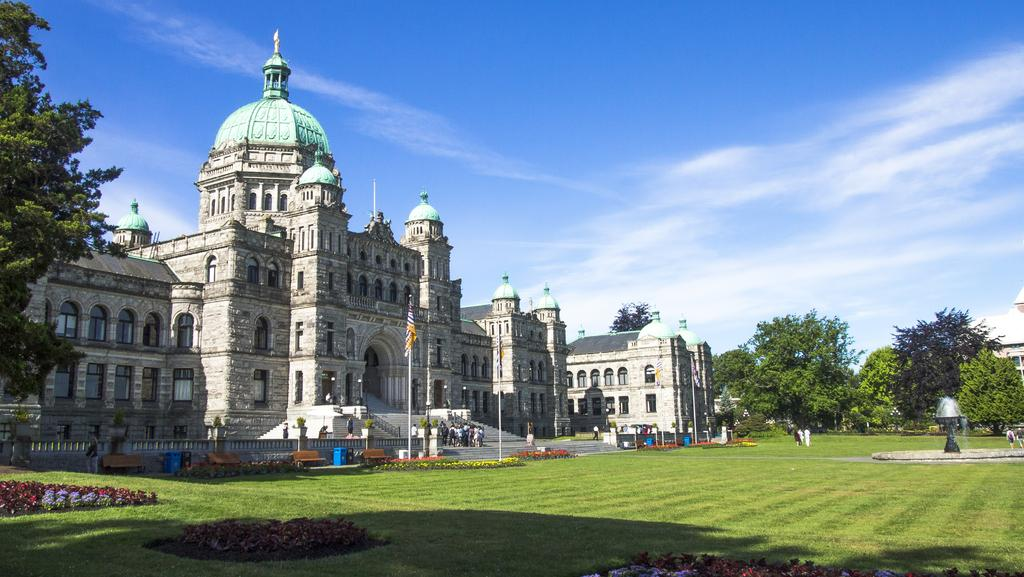What type of terrain is visible in the image? There is grass on the ground in the image. What type of structure is present in the image? There is a castle in the image. Who or what is in front of the castle? There are persons in front of the castle. What decorative elements can be seen in the image? There are flags in the image. What is the center of the image occupied by? There are trees in the center of the image. How would you describe the weather in the image? The sky is cloudy in the image. What type of paint is being used to create the castle in the image? There is no indication that the castle is being painted or created in the image; it appears to be a real, existing structure. 